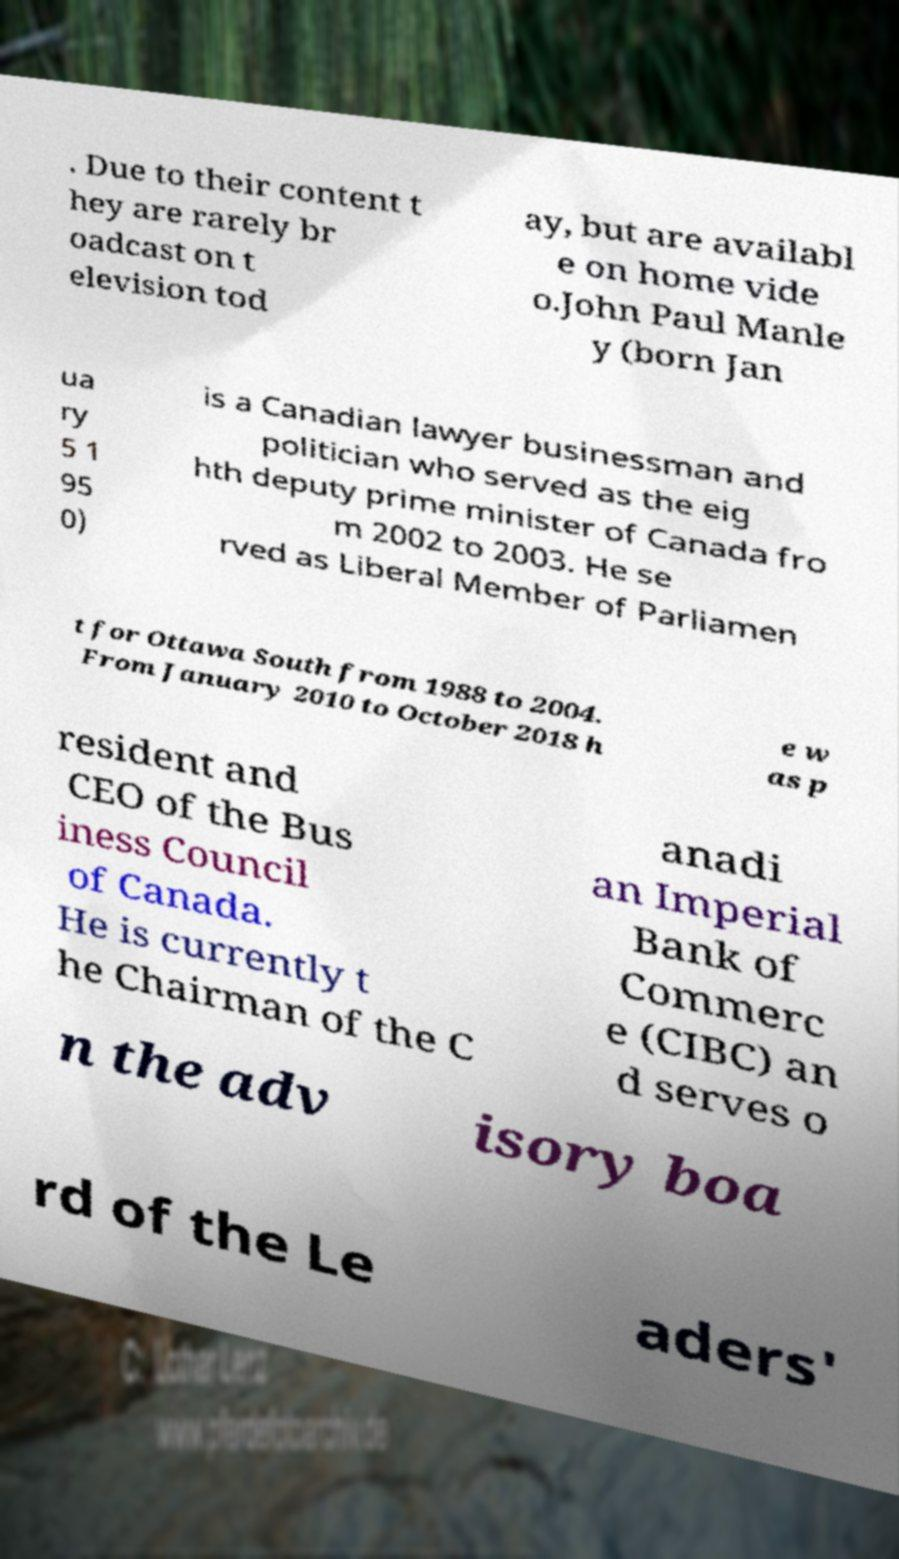There's text embedded in this image that I need extracted. Can you transcribe it verbatim? . Due to their content t hey are rarely br oadcast on t elevision tod ay, but are availabl e on home vide o.John Paul Manle y (born Jan ua ry 5 1 95 0) is a Canadian lawyer businessman and politician who served as the eig hth deputy prime minister of Canada fro m 2002 to 2003. He se rved as Liberal Member of Parliamen t for Ottawa South from 1988 to 2004. From January 2010 to October 2018 h e w as p resident and CEO of the Bus iness Council of Canada. He is currently t he Chairman of the C anadi an Imperial Bank of Commerc e (CIBC) an d serves o n the adv isory boa rd of the Le aders' 